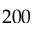<formula> <loc_0><loc_0><loc_500><loc_500>2 0 0</formula> 